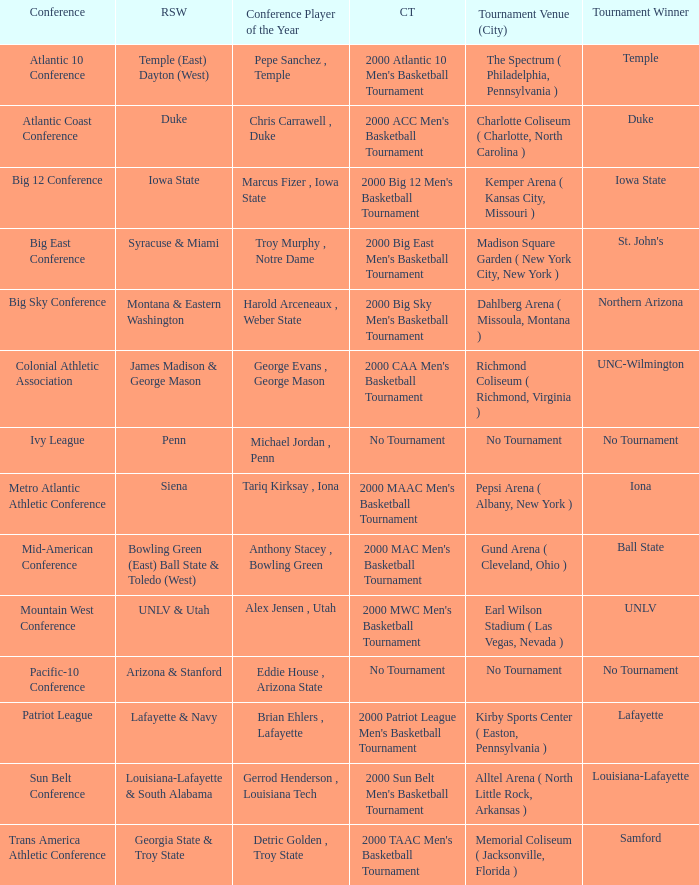What is the venue and city where the 2000 MWC Men's Basketball Tournament? Earl Wilson Stadium ( Las Vegas, Nevada ). 